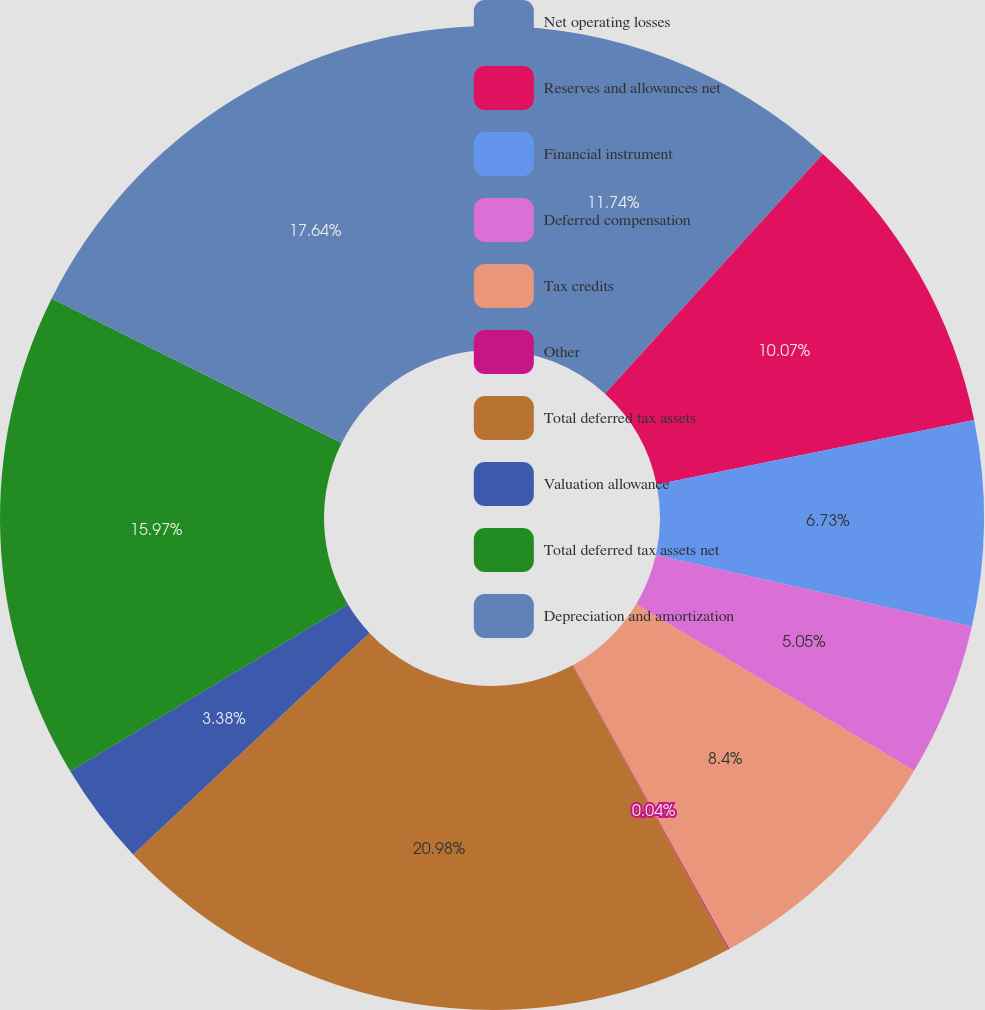Convert chart. <chart><loc_0><loc_0><loc_500><loc_500><pie_chart><fcel>Net operating losses<fcel>Reserves and allowances net<fcel>Financial instrument<fcel>Deferred compensation<fcel>Tax credits<fcel>Other<fcel>Total deferred tax assets<fcel>Valuation allowance<fcel>Total deferred tax assets net<fcel>Depreciation and amortization<nl><fcel>11.74%<fcel>10.07%<fcel>6.73%<fcel>5.05%<fcel>8.4%<fcel>0.04%<fcel>20.98%<fcel>3.38%<fcel>15.97%<fcel>17.64%<nl></chart> 